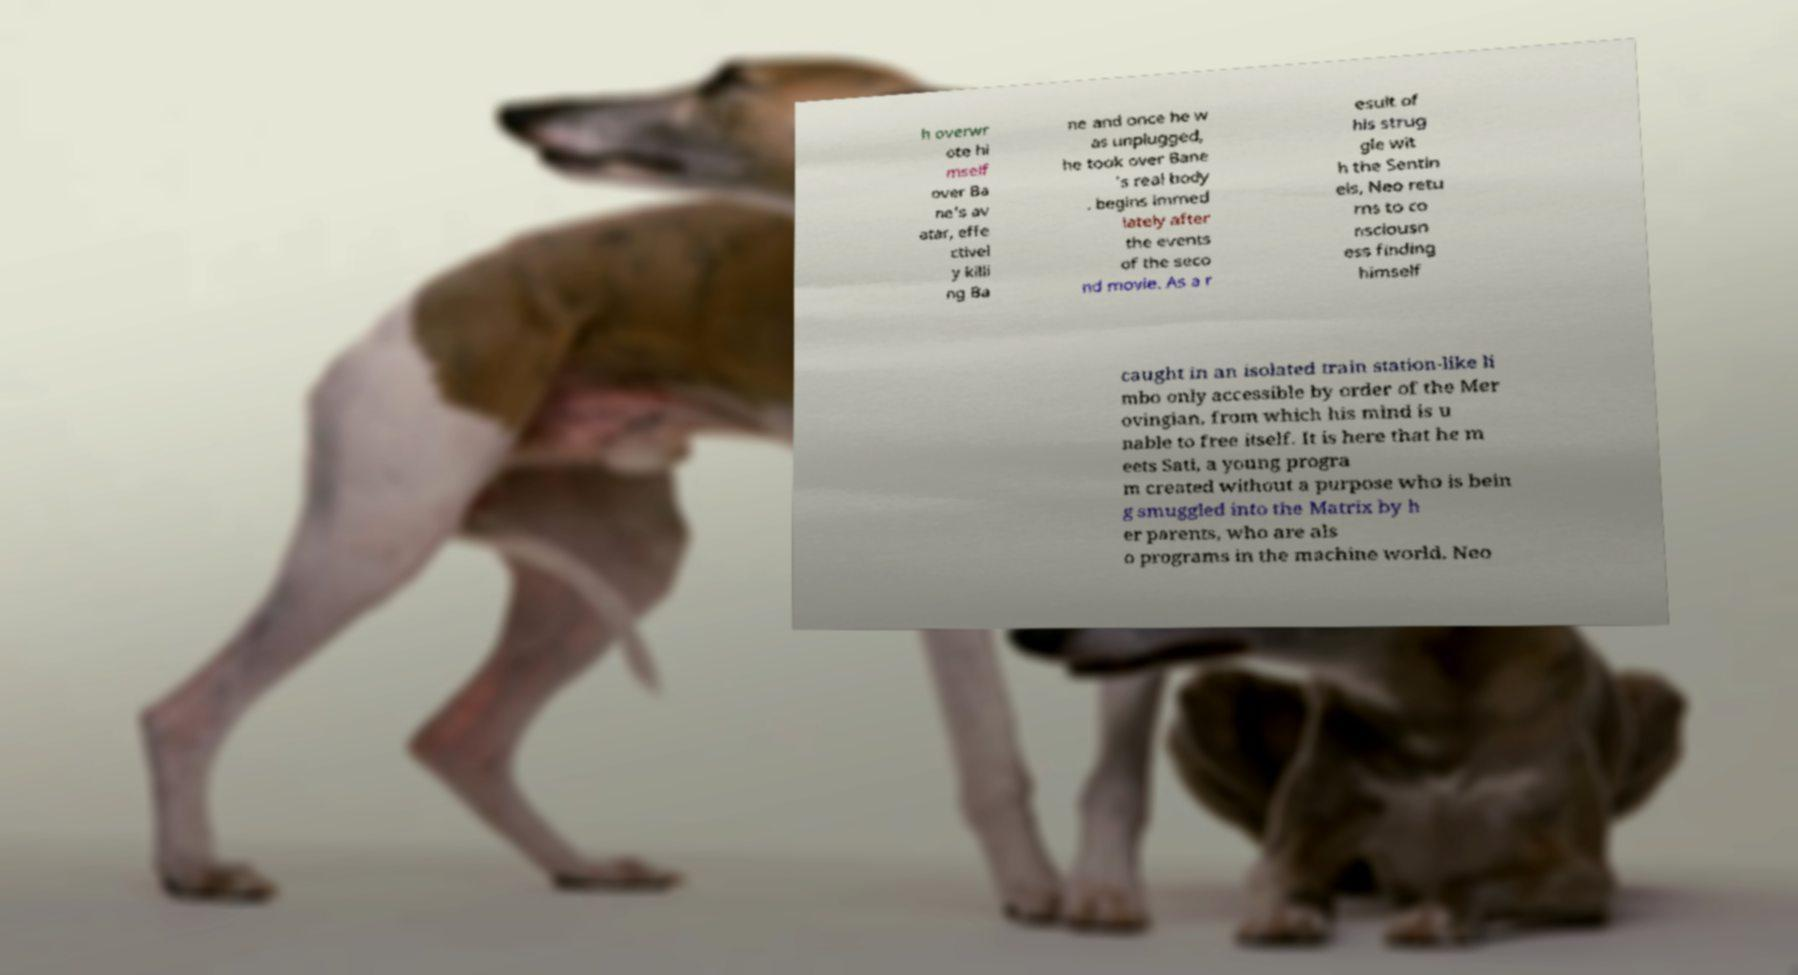There's text embedded in this image that I need extracted. Can you transcribe it verbatim? h overwr ote hi mself over Ba ne's av atar, effe ctivel y killi ng Ba ne and once he w as unplugged, he took over Bane 's real body . begins immed iately after the events of the seco nd movie. As a r esult of his strug gle wit h the Sentin els, Neo retu rns to co nsciousn ess finding himself caught in an isolated train station-like li mbo only accessible by order of the Mer ovingian, from which his mind is u nable to free itself. It is here that he m eets Sati, a young progra m created without a purpose who is bein g smuggled into the Matrix by h er parents, who are als o programs in the machine world. Neo 